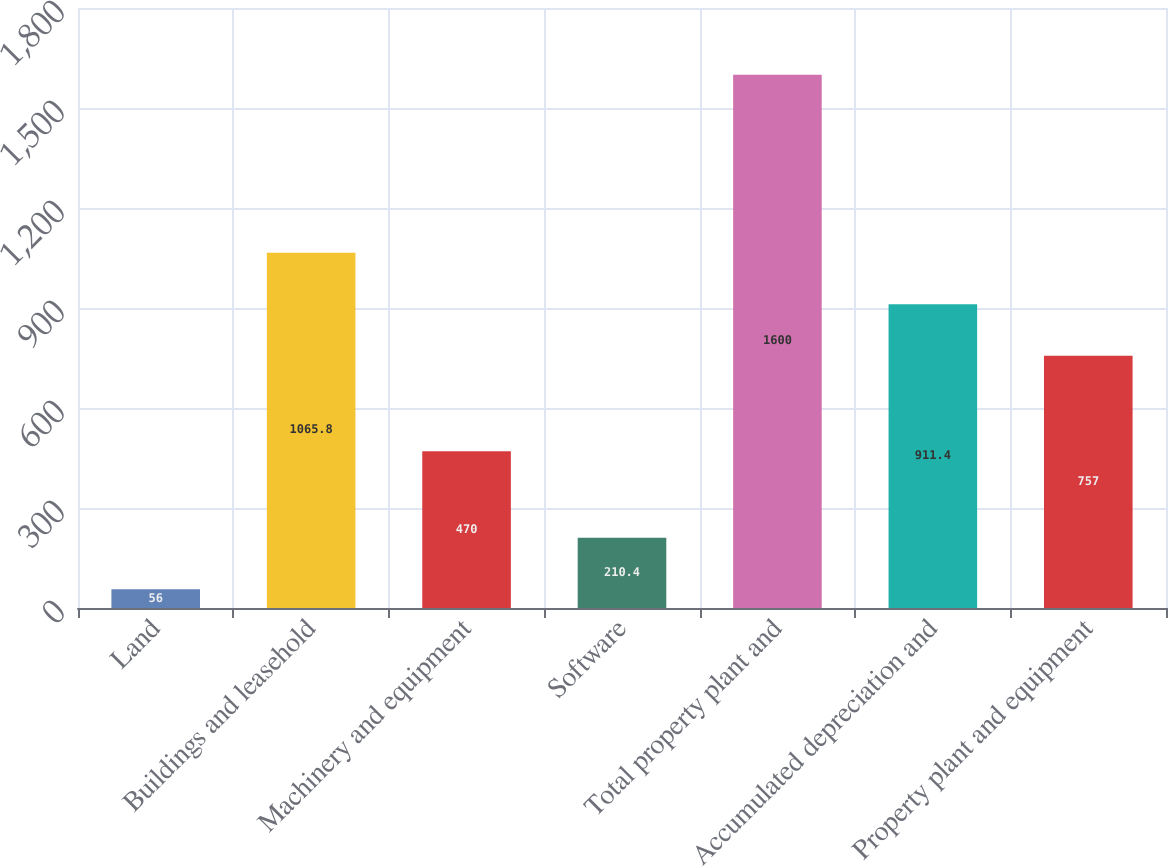<chart> <loc_0><loc_0><loc_500><loc_500><bar_chart><fcel>Land<fcel>Buildings and leasehold<fcel>Machinery and equipment<fcel>Software<fcel>Total property plant and<fcel>Accumulated depreciation and<fcel>Property plant and equipment<nl><fcel>56<fcel>1065.8<fcel>470<fcel>210.4<fcel>1600<fcel>911.4<fcel>757<nl></chart> 